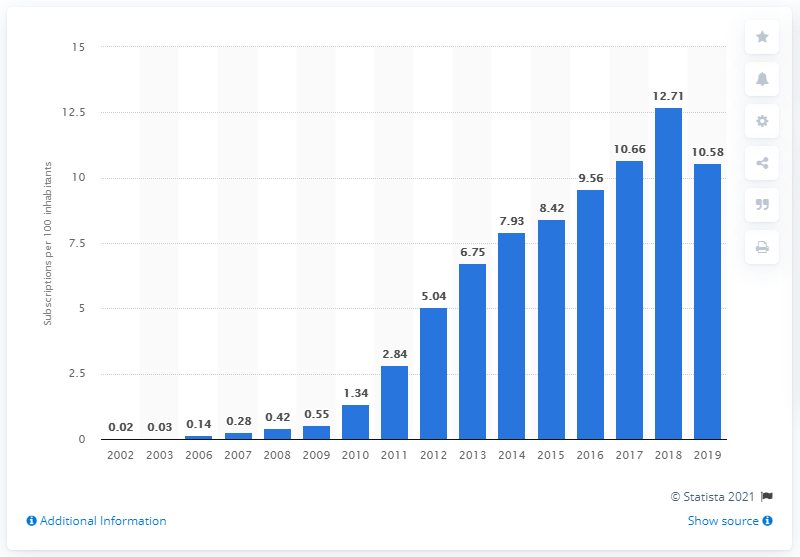Highlight a few significant elements in this photo. Between 2002 and 2019, there were an estimated 10.58 fixed broadband subscriptions for every 100 inhabitants in Iran. 